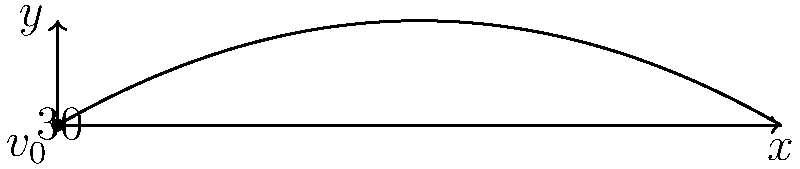As a former police officer with extensive firearms experience, you're assisting in a training exercise for new recruits. A bullet is fired from a handgun with an initial velocity of 300 m/s at an angle of 30° above the horizontal. Assuming no air resistance, calculate the maximum height reached by the bullet. Round your answer to the nearest meter. Let's approach this step-by-step:

1) The vertical component of the initial velocity is:
   $$v_{0y} = v_0 \sin \theta = 300 \sin 30° = 150 \text{ m/s}$$

2) The time to reach the maximum height is when the vertical velocity becomes zero:
   $$0 = v_{0y} - gt$$
   $$t = \frac{v_{0y}}{g} = \frac{150}{9.8} = 15.31 \text{ seconds}$$

3) The maximum height can be calculated using the equation:
   $$y = v_{0y}t - \frac{1}{2}gt^2$$

4) Substituting the values:
   $$y = 150 \times 15.31 - \frac{1}{2} \times 9.8 \times 15.31^2$$
   $$y = 2296.5 - 1147.25 = 1149.25 \text{ meters}$$

5) Rounding to the nearest meter:
   $$y \approx 1149 \text{ meters}$$

This calculation assumes ideal conditions without air resistance. In real-world scenarios, air resistance would significantly affect the bullet's trajectory, reducing its maximum height and range.
Answer: 1149 meters 